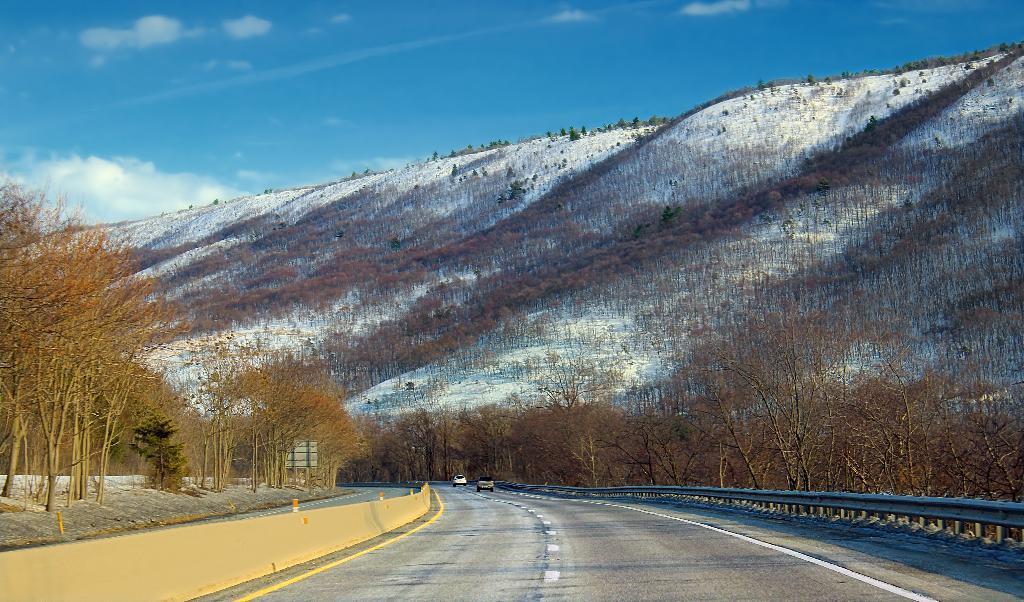Can you describe this image briefly? In this image I can see a road in the centre and on it I can see two vehicles. On the both sides of the road I can see number of trees. On the left side of this image I can see the wall and few poles. In the background I can see the mountain, clouds, the sky and I can also see snow on the mountain. 